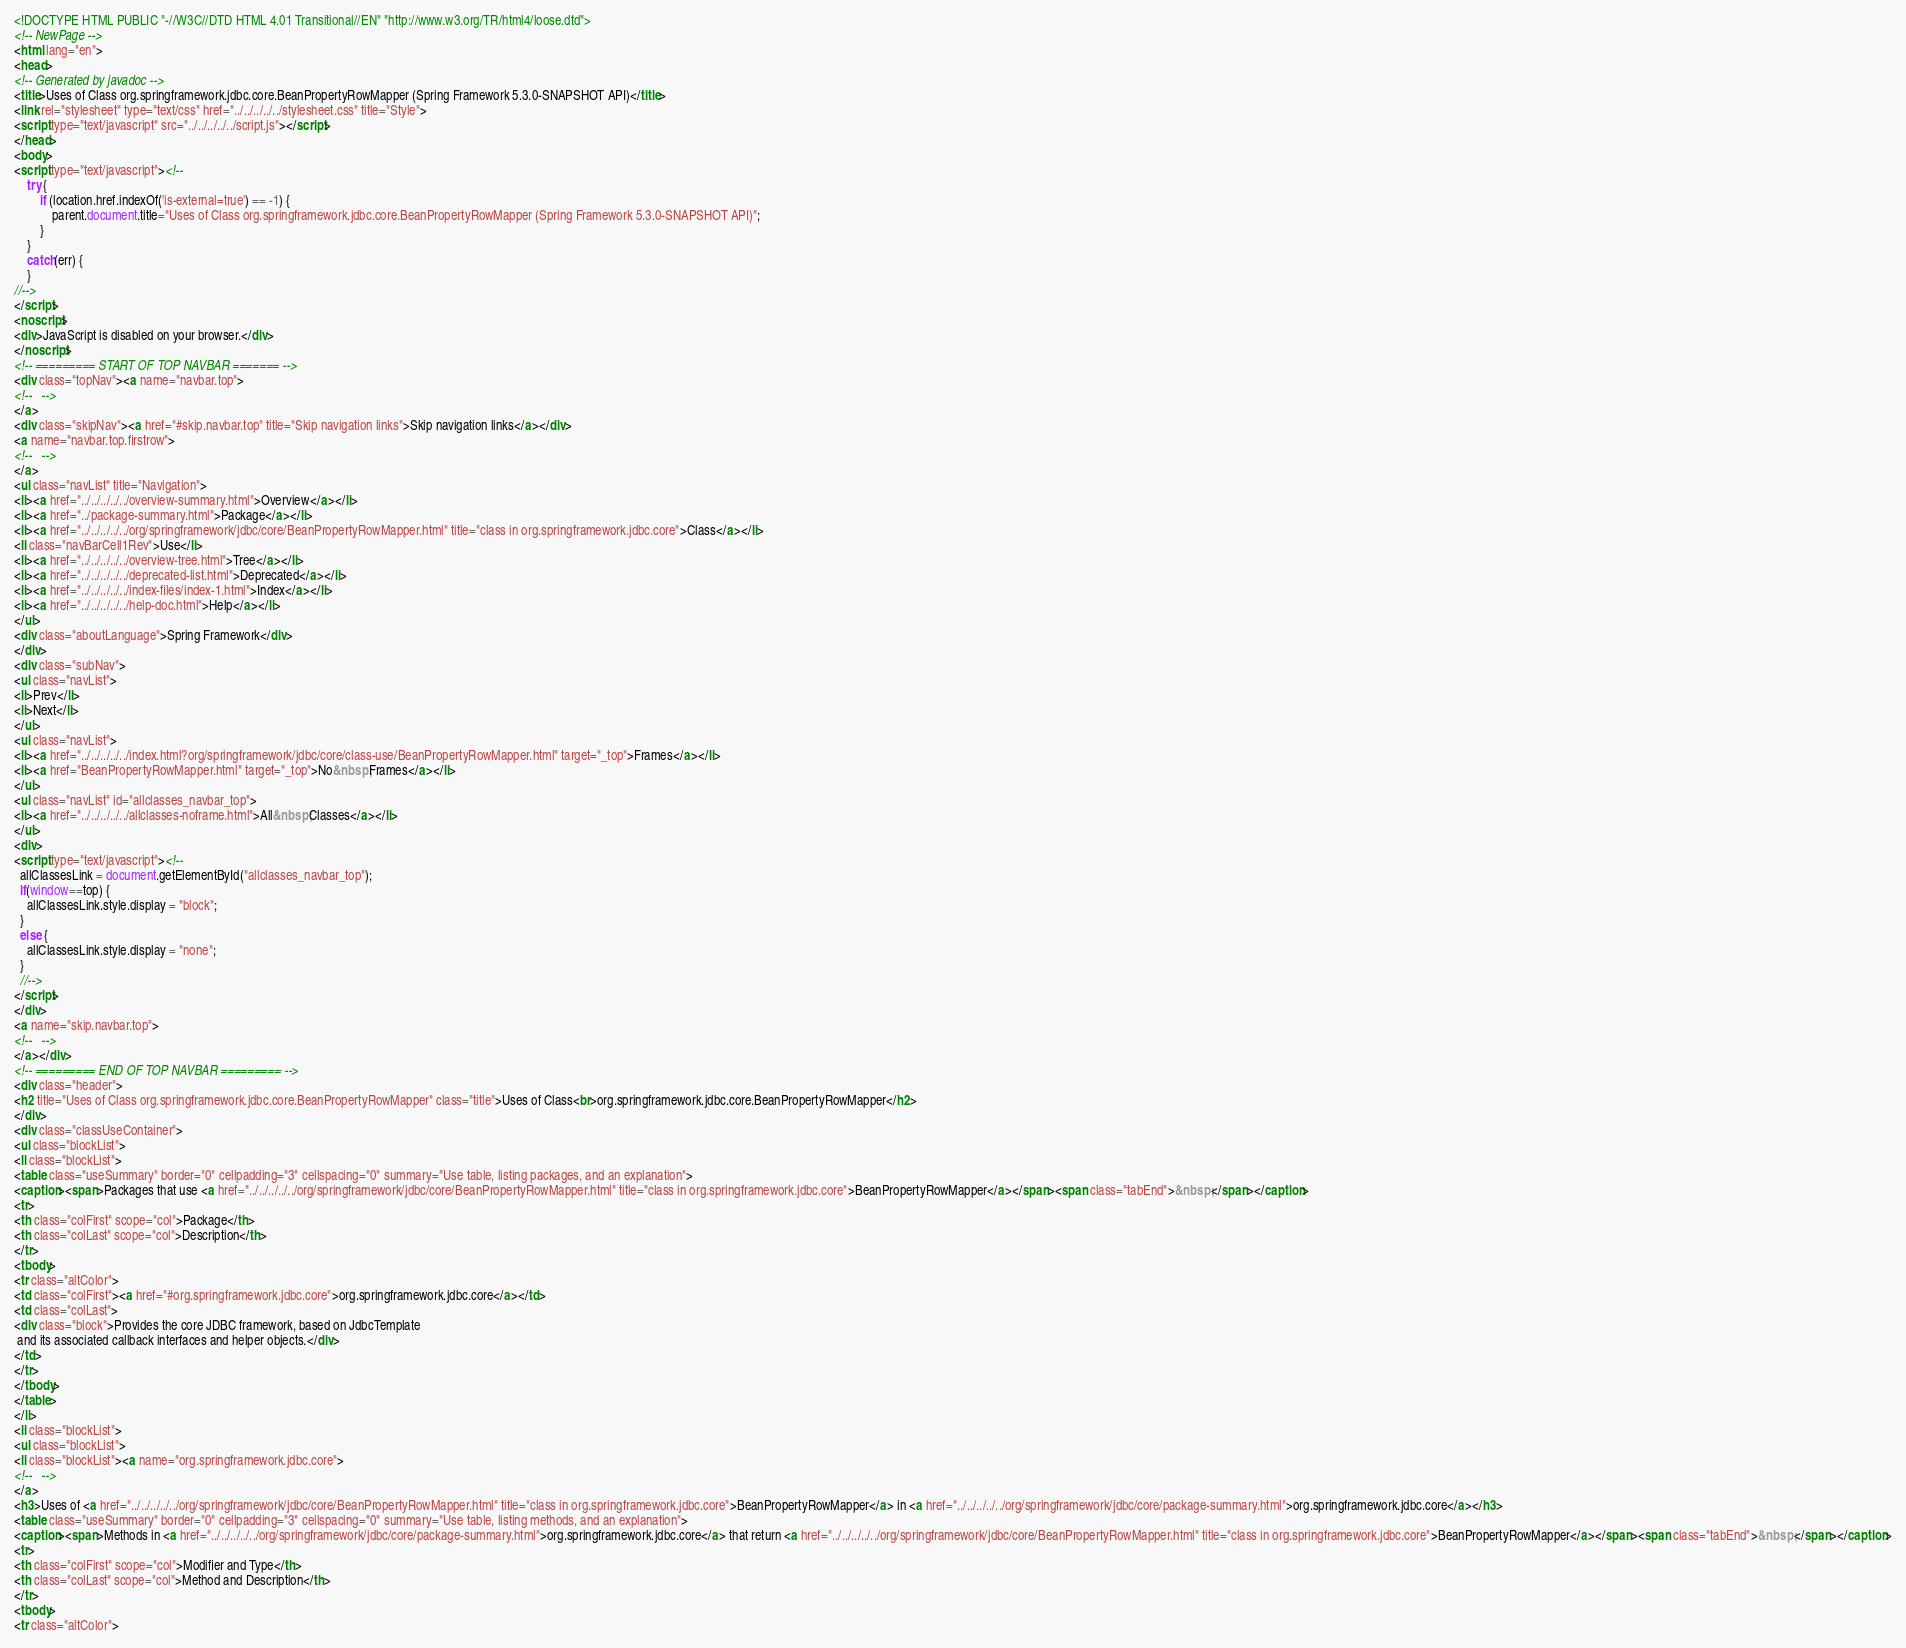Convert code to text. <code><loc_0><loc_0><loc_500><loc_500><_HTML_><!DOCTYPE HTML PUBLIC "-//W3C//DTD HTML 4.01 Transitional//EN" "http://www.w3.org/TR/html4/loose.dtd">
<!-- NewPage -->
<html lang="en">
<head>
<!-- Generated by javadoc -->
<title>Uses of Class org.springframework.jdbc.core.BeanPropertyRowMapper (Spring Framework 5.3.0-SNAPSHOT API)</title>
<link rel="stylesheet" type="text/css" href="../../../../../stylesheet.css" title="Style">
<script type="text/javascript" src="../../../../../script.js"></script>
</head>
<body>
<script type="text/javascript"><!--
    try {
        if (location.href.indexOf('is-external=true') == -1) {
            parent.document.title="Uses of Class org.springframework.jdbc.core.BeanPropertyRowMapper (Spring Framework 5.3.0-SNAPSHOT API)";
        }
    }
    catch(err) {
    }
//-->
</script>
<noscript>
<div>JavaScript is disabled on your browser.</div>
</noscript>
<!-- ========= START OF TOP NAVBAR ======= -->
<div class="topNav"><a name="navbar.top">
<!--   -->
</a>
<div class="skipNav"><a href="#skip.navbar.top" title="Skip navigation links">Skip navigation links</a></div>
<a name="navbar.top.firstrow">
<!--   -->
</a>
<ul class="navList" title="Navigation">
<li><a href="../../../../../overview-summary.html">Overview</a></li>
<li><a href="../package-summary.html">Package</a></li>
<li><a href="../../../../../org/springframework/jdbc/core/BeanPropertyRowMapper.html" title="class in org.springframework.jdbc.core">Class</a></li>
<li class="navBarCell1Rev">Use</li>
<li><a href="../../../../../overview-tree.html">Tree</a></li>
<li><a href="../../../../../deprecated-list.html">Deprecated</a></li>
<li><a href="../../../../../index-files/index-1.html">Index</a></li>
<li><a href="../../../../../help-doc.html">Help</a></li>
</ul>
<div class="aboutLanguage">Spring Framework</div>
</div>
<div class="subNav">
<ul class="navList">
<li>Prev</li>
<li>Next</li>
</ul>
<ul class="navList">
<li><a href="../../../../../index.html?org/springframework/jdbc/core/class-use/BeanPropertyRowMapper.html" target="_top">Frames</a></li>
<li><a href="BeanPropertyRowMapper.html" target="_top">No&nbsp;Frames</a></li>
</ul>
<ul class="navList" id="allclasses_navbar_top">
<li><a href="../../../../../allclasses-noframe.html">All&nbsp;Classes</a></li>
</ul>
<div>
<script type="text/javascript"><!--
  allClassesLink = document.getElementById("allclasses_navbar_top");
  if(window==top) {
    allClassesLink.style.display = "block";
  }
  else {
    allClassesLink.style.display = "none";
  }
  //-->
</script>
</div>
<a name="skip.navbar.top">
<!--   -->
</a></div>
<!-- ========= END OF TOP NAVBAR ========= -->
<div class="header">
<h2 title="Uses of Class org.springframework.jdbc.core.BeanPropertyRowMapper" class="title">Uses of Class<br>org.springframework.jdbc.core.BeanPropertyRowMapper</h2>
</div>
<div class="classUseContainer">
<ul class="blockList">
<li class="blockList">
<table class="useSummary" border="0" cellpadding="3" cellspacing="0" summary="Use table, listing packages, and an explanation">
<caption><span>Packages that use <a href="../../../../../org/springframework/jdbc/core/BeanPropertyRowMapper.html" title="class in org.springframework.jdbc.core">BeanPropertyRowMapper</a></span><span class="tabEnd">&nbsp;</span></caption>
<tr>
<th class="colFirst" scope="col">Package</th>
<th class="colLast" scope="col">Description</th>
</tr>
<tbody>
<tr class="altColor">
<td class="colFirst"><a href="#org.springframework.jdbc.core">org.springframework.jdbc.core</a></td>
<td class="colLast">
<div class="block">Provides the core JDBC framework, based on JdbcTemplate
 and its associated callback interfaces and helper objects.</div>
</td>
</tr>
</tbody>
</table>
</li>
<li class="blockList">
<ul class="blockList">
<li class="blockList"><a name="org.springframework.jdbc.core">
<!--   -->
</a>
<h3>Uses of <a href="../../../../../org/springframework/jdbc/core/BeanPropertyRowMapper.html" title="class in org.springframework.jdbc.core">BeanPropertyRowMapper</a> in <a href="../../../../../org/springframework/jdbc/core/package-summary.html">org.springframework.jdbc.core</a></h3>
<table class="useSummary" border="0" cellpadding="3" cellspacing="0" summary="Use table, listing methods, and an explanation">
<caption><span>Methods in <a href="../../../../../org/springframework/jdbc/core/package-summary.html">org.springframework.jdbc.core</a> that return <a href="../../../../../org/springframework/jdbc/core/BeanPropertyRowMapper.html" title="class in org.springframework.jdbc.core">BeanPropertyRowMapper</a></span><span class="tabEnd">&nbsp;</span></caption>
<tr>
<th class="colFirst" scope="col">Modifier and Type</th>
<th class="colLast" scope="col">Method and Description</th>
</tr>
<tbody>
<tr class="altColor"></code> 